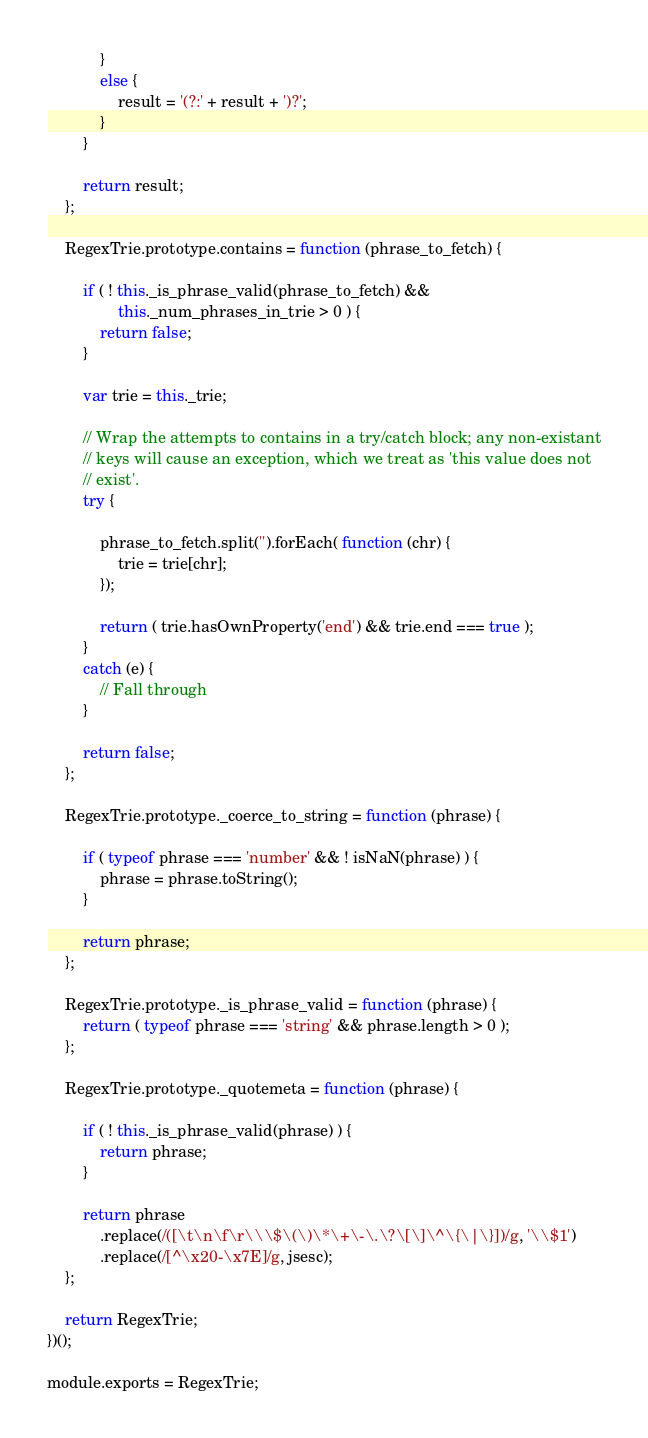<code> <loc_0><loc_0><loc_500><loc_500><_JavaScript_>            }
            else {
                result = '(?:' + result + ')?';
            }
        }

        return result;
    };

    RegexTrie.prototype.contains = function (phrase_to_fetch) {

        if ( ! this._is_phrase_valid(phrase_to_fetch) &&
                this._num_phrases_in_trie > 0 ) {
            return false;
        }

        var trie = this._trie;

        // Wrap the attempts to contains in a try/catch block; any non-existant
        // keys will cause an exception, which we treat as 'this value does not
        // exist'.
        try {

            phrase_to_fetch.split('').forEach( function (chr) {
                trie = trie[chr];
            });

            return ( trie.hasOwnProperty('end') && trie.end === true );
        }
        catch (e) {
            // Fall through
        }

        return false;
    };

    RegexTrie.prototype._coerce_to_string = function (phrase) {

        if ( typeof phrase === 'number' && ! isNaN(phrase) ) {
            phrase = phrase.toString();
        }

        return phrase;
    };

    RegexTrie.prototype._is_phrase_valid = function (phrase) {
        return ( typeof phrase === 'string' && phrase.length > 0 );
    };

    RegexTrie.prototype._quotemeta = function (phrase) {

        if ( ! this._is_phrase_valid(phrase) ) {
            return phrase;
        }

        return phrase
            .replace(/([\t\n\f\r\\\$\(\)\*\+\-\.\?\[\]\^\{\|\}])/g, '\\$1')
            .replace(/[^\x20-\x7E]/g, jsesc);
    };

    return RegexTrie;
})();

module.exports = RegexTrie;
</code> 